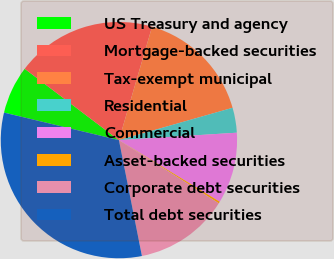Convert chart. <chart><loc_0><loc_0><loc_500><loc_500><pie_chart><fcel>US Treasury and agency<fcel>Mortgage-backed securities<fcel>Tax-exempt municipal<fcel>Residential<fcel>Commercial<fcel>Asset-backed securities<fcel>Corporate debt securities<fcel>Total debt securities<nl><fcel>6.57%<fcel>19.22%<fcel>16.06%<fcel>3.41%<fcel>9.73%<fcel>0.25%<fcel>12.9%<fcel>31.86%<nl></chart> 